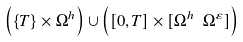<formula> <loc_0><loc_0><loc_500><loc_500>\left ( \{ T \} \times \Omega ^ { h } \right ) \cup \left ( [ 0 , T ] \times [ \Omega ^ { h } \ \Omega ^ { \varepsilon } ] \right )</formula> 